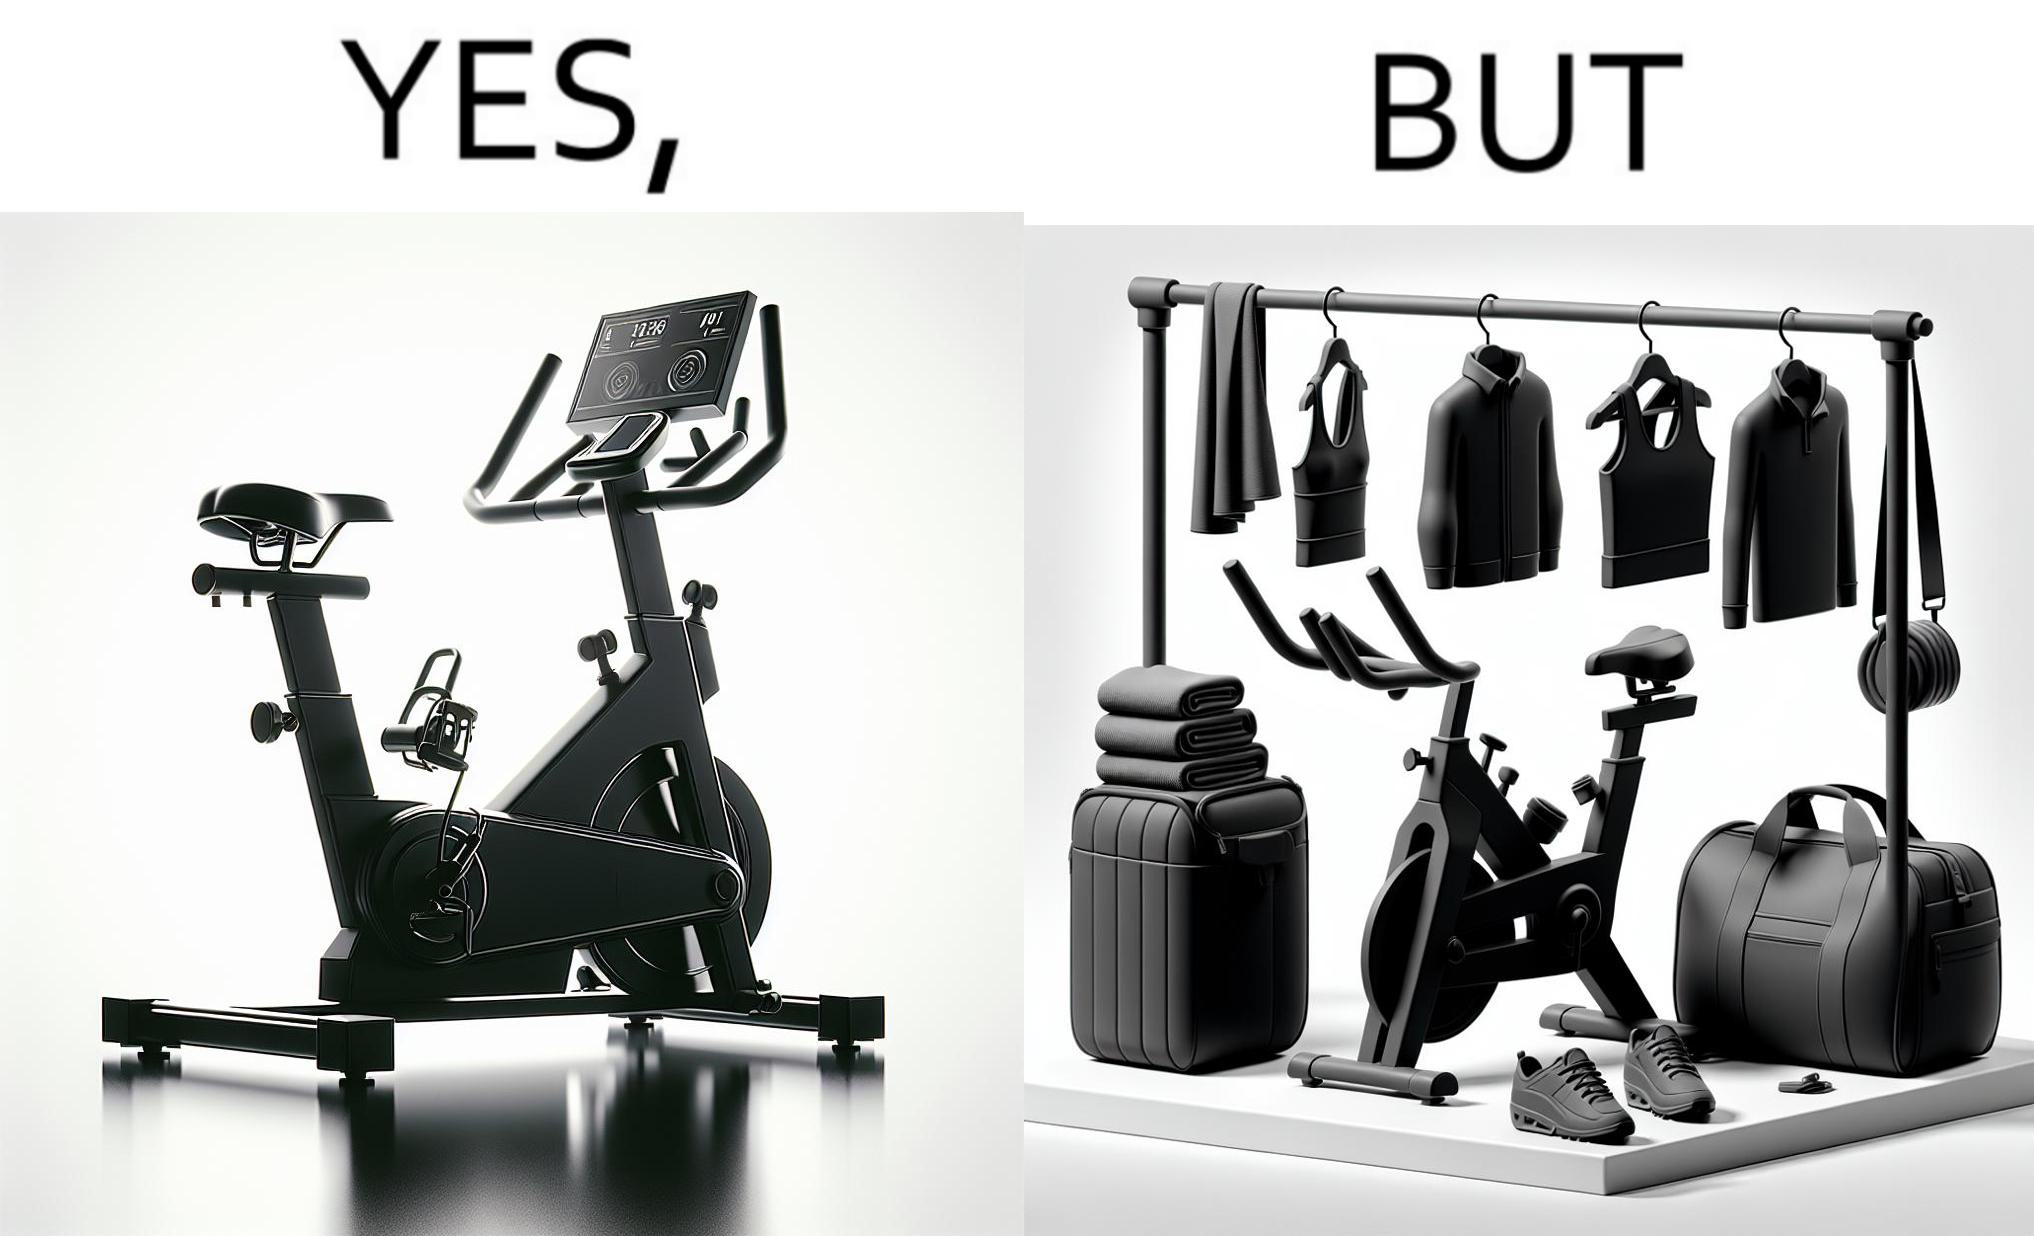Would you classify this image as satirical? Yes, this image is satirical. 